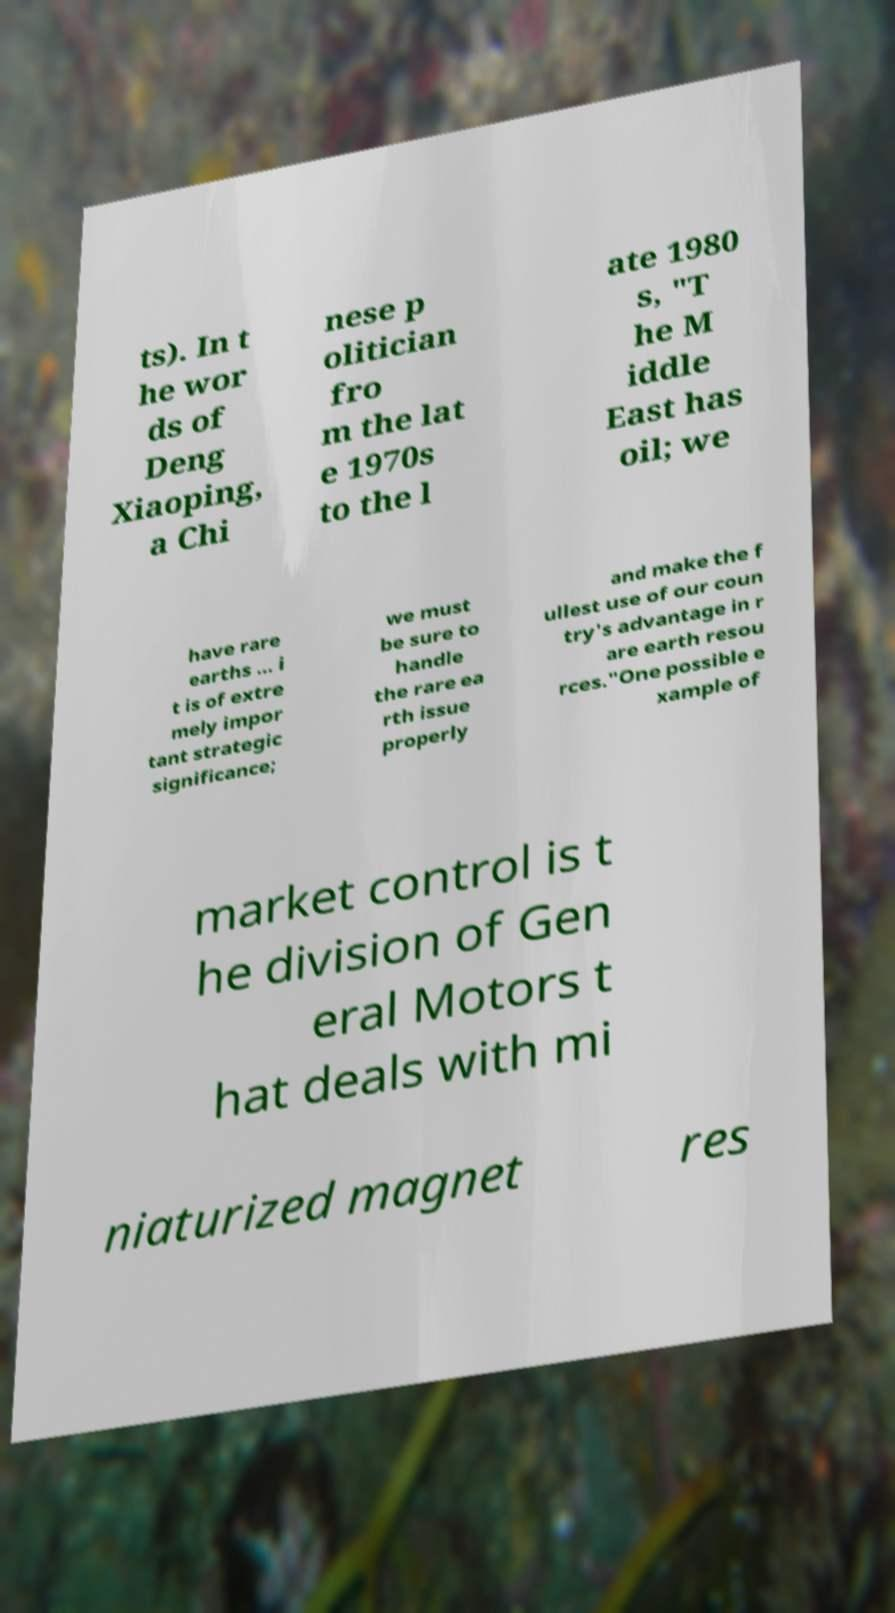For documentation purposes, I need the text within this image transcribed. Could you provide that? ts). In t he wor ds of Deng Xiaoping, a Chi nese p olitician fro m the lat e 1970s to the l ate 1980 s, "T he M iddle East has oil; we have rare earths ... i t is of extre mely impor tant strategic significance; we must be sure to handle the rare ea rth issue properly and make the f ullest use of our coun try's advantage in r are earth resou rces."One possible e xample of market control is t he division of Gen eral Motors t hat deals with mi niaturized magnet res 